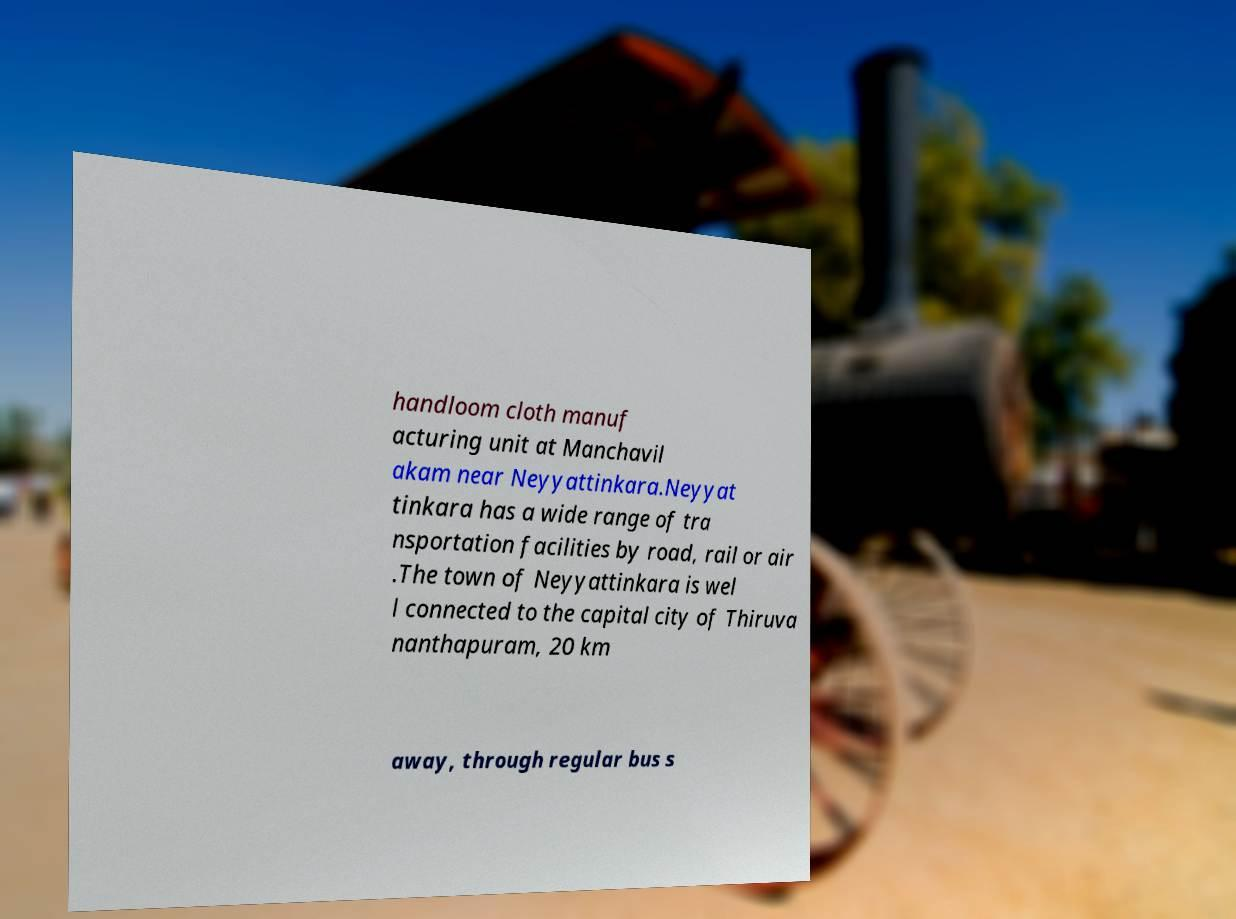Could you assist in decoding the text presented in this image and type it out clearly? handloom cloth manuf acturing unit at Manchavil akam near Neyyattinkara.Neyyat tinkara has a wide range of tra nsportation facilities by road, rail or air .The town of Neyyattinkara is wel l connected to the capital city of Thiruva nanthapuram, 20 km away, through regular bus s 